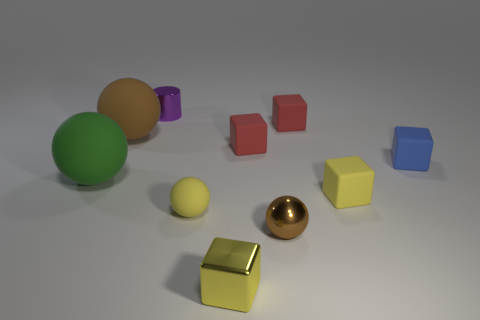Subtract all small rubber spheres. How many spheres are left? 3 Subtract all yellow cubes. How many cubes are left? 3 Subtract 1 cylinders. How many cylinders are left? 0 Subtract all balls. How many objects are left? 6 Subtract all cyan blocks. How many green cylinders are left? 0 Add 2 large rubber spheres. How many large rubber spheres are left? 4 Add 8 small yellow metal spheres. How many small yellow metal spheres exist? 8 Subtract 0 gray spheres. How many objects are left? 10 Subtract all blue blocks. Subtract all gray spheres. How many blocks are left? 4 Subtract all big red matte objects. Subtract all purple things. How many objects are left? 9 